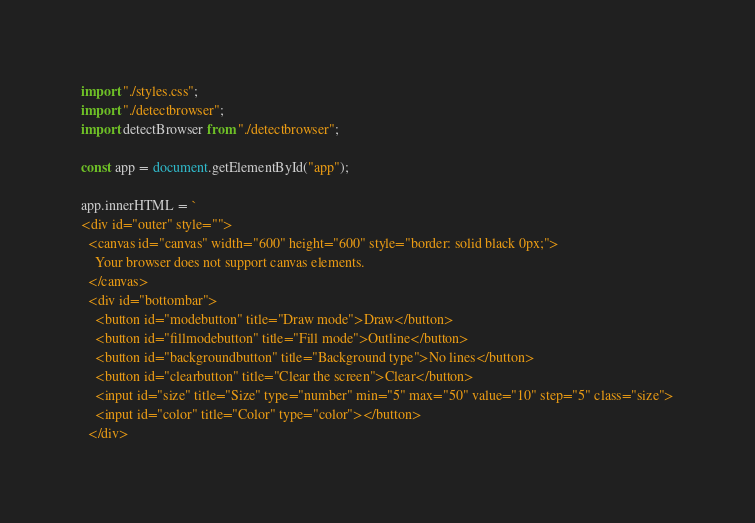<code> <loc_0><loc_0><loc_500><loc_500><_JavaScript_>import "./styles.css";
import "./detectbrowser";
import detectBrowser from "./detectbrowser";

const app = document.getElementById("app");

app.innerHTML = `
<div id="outer" style="">
  <canvas id="canvas" width="600" height="600" style="border: solid black 0px;">
    Your browser does not support canvas elements.
  </canvas>
  <div id="bottombar">
    <button id="modebutton" title="Draw mode">Draw</button>
    <button id="fillmodebutton" title="Fill mode">Outline</button>
    <button id="backgroundbutton" title="Background type">No lines</button>
    <button id="clearbutton" title="Clear the screen">Clear</button>
    <input id="size" title="Size" type="number" min="5" max="50" value="10" step="5" class="size">
    <input id="color" title="Color" type="color"></button>
  </div></code> 